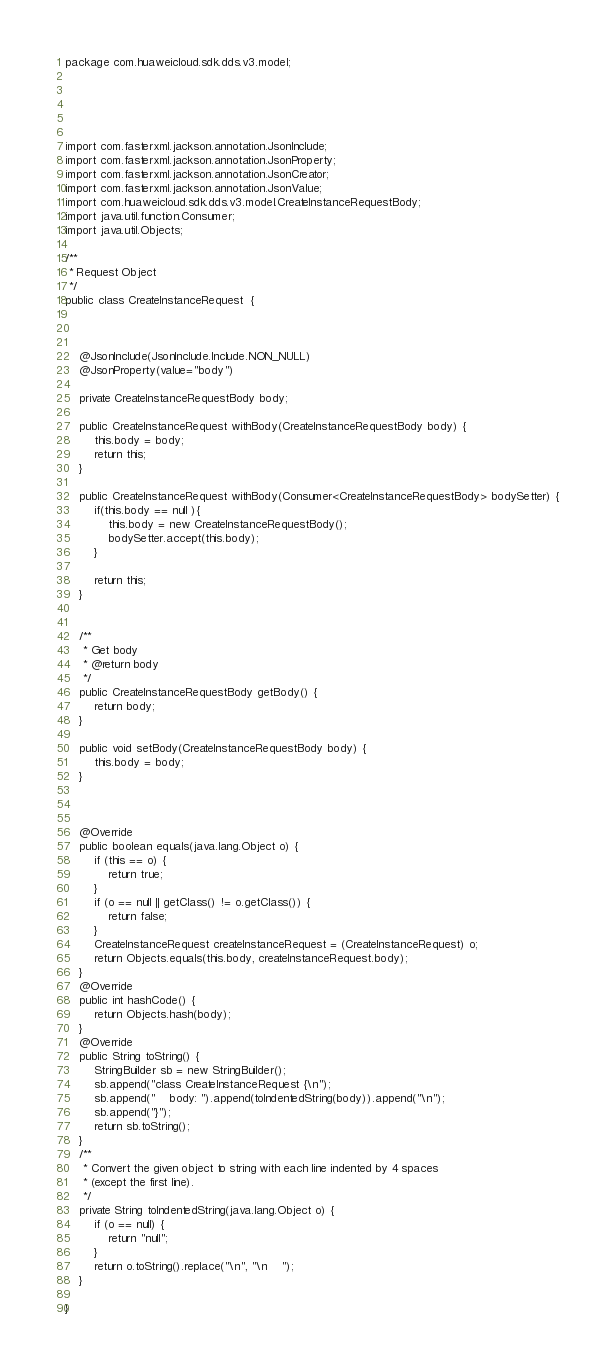Convert code to text. <code><loc_0><loc_0><loc_500><loc_500><_Java_>package com.huaweicloud.sdk.dds.v3.model;





import com.fasterxml.jackson.annotation.JsonInclude;
import com.fasterxml.jackson.annotation.JsonProperty;
import com.fasterxml.jackson.annotation.JsonCreator;
import com.fasterxml.jackson.annotation.JsonValue;
import com.huaweicloud.sdk.dds.v3.model.CreateInstanceRequestBody;
import java.util.function.Consumer;
import java.util.Objects;

/**
 * Request Object
 */
public class CreateInstanceRequest  {



    @JsonInclude(JsonInclude.Include.NON_NULL)
    @JsonProperty(value="body")
    
    private CreateInstanceRequestBody body;

    public CreateInstanceRequest withBody(CreateInstanceRequestBody body) {
        this.body = body;
        return this;
    }

    public CreateInstanceRequest withBody(Consumer<CreateInstanceRequestBody> bodySetter) {
        if(this.body == null ){
            this.body = new CreateInstanceRequestBody();
            bodySetter.accept(this.body);
        }
        
        return this;
    }


    /**
     * Get body
     * @return body
     */
    public CreateInstanceRequestBody getBody() {
        return body;
    }

    public void setBody(CreateInstanceRequestBody body) {
        this.body = body;
    }

    

    @Override
    public boolean equals(java.lang.Object o) {
        if (this == o) {
            return true;
        }
        if (o == null || getClass() != o.getClass()) {
            return false;
        }
        CreateInstanceRequest createInstanceRequest = (CreateInstanceRequest) o;
        return Objects.equals(this.body, createInstanceRequest.body);
    }
    @Override
    public int hashCode() {
        return Objects.hash(body);
    }
    @Override
    public String toString() {
        StringBuilder sb = new StringBuilder();
        sb.append("class CreateInstanceRequest {\n");
        sb.append("    body: ").append(toIndentedString(body)).append("\n");
        sb.append("}");
        return sb.toString();
    }
    /**
     * Convert the given object to string with each line indented by 4 spaces
     * (except the first line).
     */
    private String toIndentedString(java.lang.Object o) {
        if (o == null) {
            return "null";
        }
        return o.toString().replace("\n", "\n    ");
    }
    
}

</code> 